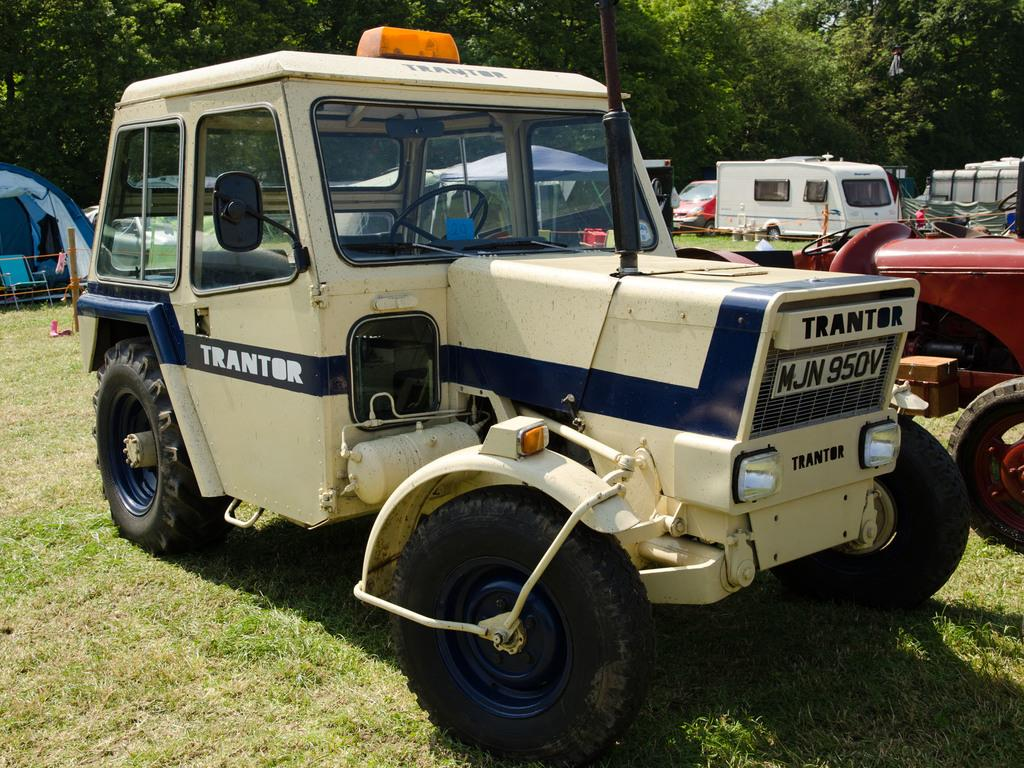What is located in the center of the image? There are vehicles, barricades, a chair, and a tent in the center of the image. What type of objects are present in the center of the image? The objects in the center of the image include vehicles, barricades, a chair, and a tent. What can be seen in the background of the image? There are trees in the background of the image. What is visible at the bottom of the image? The ground is visible at the bottom of the image. What is the title of the book that is being read by the laborer in the image? There is no book or laborer present in the image. How can the items in the image be sorted by color? The provided facts do not mention any colors, so it is not possible to sort the items by color. 